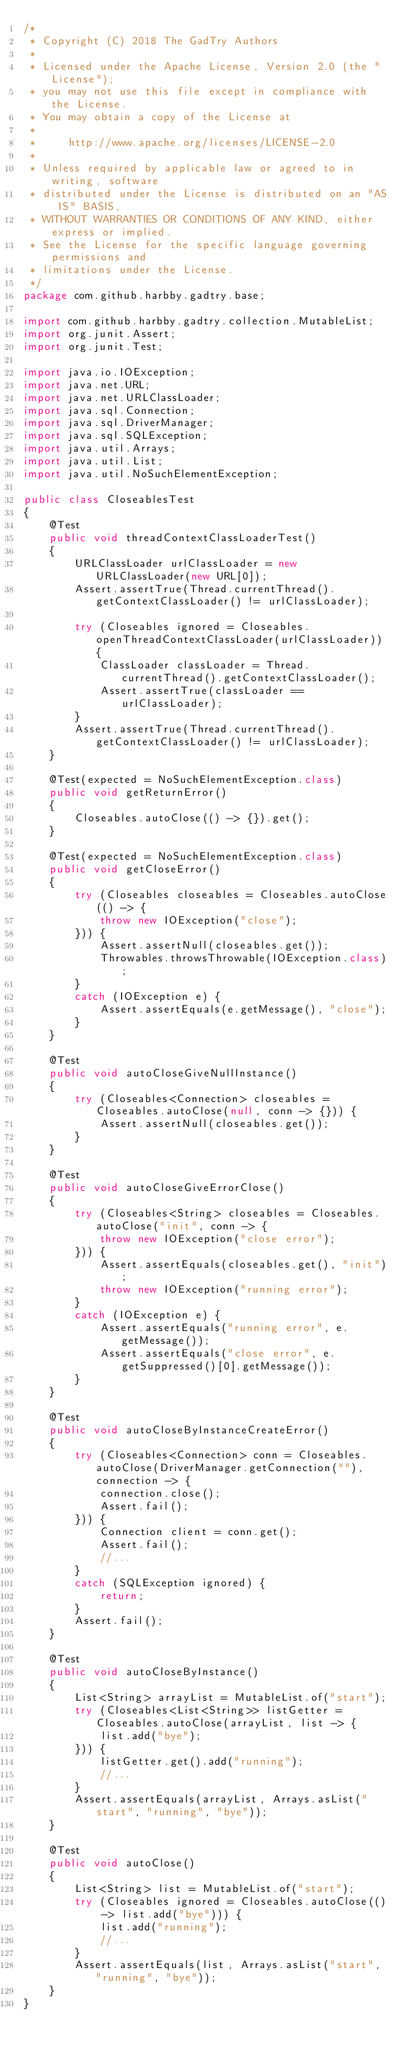<code> <loc_0><loc_0><loc_500><loc_500><_Java_>/*
 * Copyright (C) 2018 The GadTry Authors
 *
 * Licensed under the Apache License, Version 2.0 (the "License");
 * you may not use this file except in compliance with the License.
 * You may obtain a copy of the License at
 *
 *     http://www.apache.org/licenses/LICENSE-2.0
 *
 * Unless required by applicable law or agreed to in writing, software
 * distributed under the License is distributed on an "AS IS" BASIS,
 * WITHOUT WARRANTIES OR CONDITIONS OF ANY KIND, either express or implied.
 * See the License for the specific language governing permissions and
 * limitations under the License.
 */
package com.github.harbby.gadtry.base;

import com.github.harbby.gadtry.collection.MutableList;
import org.junit.Assert;
import org.junit.Test;

import java.io.IOException;
import java.net.URL;
import java.net.URLClassLoader;
import java.sql.Connection;
import java.sql.DriverManager;
import java.sql.SQLException;
import java.util.Arrays;
import java.util.List;
import java.util.NoSuchElementException;

public class CloseablesTest
{
    @Test
    public void threadContextClassLoaderTest()
    {
        URLClassLoader urlClassLoader = new URLClassLoader(new URL[0]);
        Assert.assertTrue(Thread.currentThread().getContextClassLoader() != urlClassLoader);

        try (Closeables ignored = Closeables.openThreadContextClassLoader(urlClassLoader)) {
            ClassLoader classLoader = Thread.currentThread().getContextClassLoader();
            Assert.assertTrue(classLoader == urlClassLoader);
        }
        Assert.assertTrue(Thread.currentThread().getContextClassLoader() != urlClassLoader);
    }

    @Test(expected = NoSuchElementException.class)
    public void getReturnError()
    {
        Closeables.autoClose(() -> {}).get();
    }

    @Test(expected = NoSuchElementException.class)
    public void getCloseError()
    {
        try (Closeables closeables = Closeables.autoClose(() -> {
            throw new IOException("close");
        })) {
            Assert.assertNull(closeables.get());
            Throwables.throwsThrowable(IOException.class);
        }
        catch (IOException e) {
            Assert.assertEquals(e.getMessage(), "close");
        }
    }

    @Test
    public void autoCloseGiveNullInstance()
    {
        try (Closeables<Connection> closeables = Closeables.autoClose(null, conn -> {})) {
            Assert.assertNull(closeables.get());
        }
    }

    @Test
    public void autoCloseGiveErrorClose()
    {
        try (Closeables<String> closeables = Closeables.autoClose("init", conn -> {
            throw new IOException("close error");
        })) {
            Assert.assertEquals(closeables.get(), "init");
            throw new IOException("running error");
        }
        catch (IOException e) {
            Assert.assertEquals("running error", e.getMessage());
            Assert.assertEquals("close error", e.getSuppressed()[0].getMessage());
        }
    }

    @Test
    public void autoCloseByInstanceCreateError()
    {
        try (Closeables<Connection> conn = Closeables.autoClose(DriverManager.getConnection(""), connection -> {
            connection.close();
            Assert.fail();
        })) {
            Connection client = conn.get();
            Assert.fail();
            //...
        }
        catch (SQLException ignored) {
            return;
        }
        Assert.fail();
    }

    @Test
    public void autoCloseByInstance()
    {
        List<String> arrayList = MutableList.of("start");
        try (Closeables<List<String>> listGetter = Closeables.autoClose(arrayList, list -> {
            list.add("bye");
        })) {
            listGetter.get().add("running");
            //...
        }
        Assert.assertEquals(arrayList, Arrays.asList("start", "running", "bye"));
    }

    @Test
    public void autoClose()
    {
        List<String> list = MutableList.of("start");
        try (Closeables ignored = Closeables.autoClose(() -> list.add("bye"))) {
            list.add("running");
            //...
        }
        Assert.assertEquals(list, Arrays.asList("start", "running", "bye"));
    }
}
</code> 